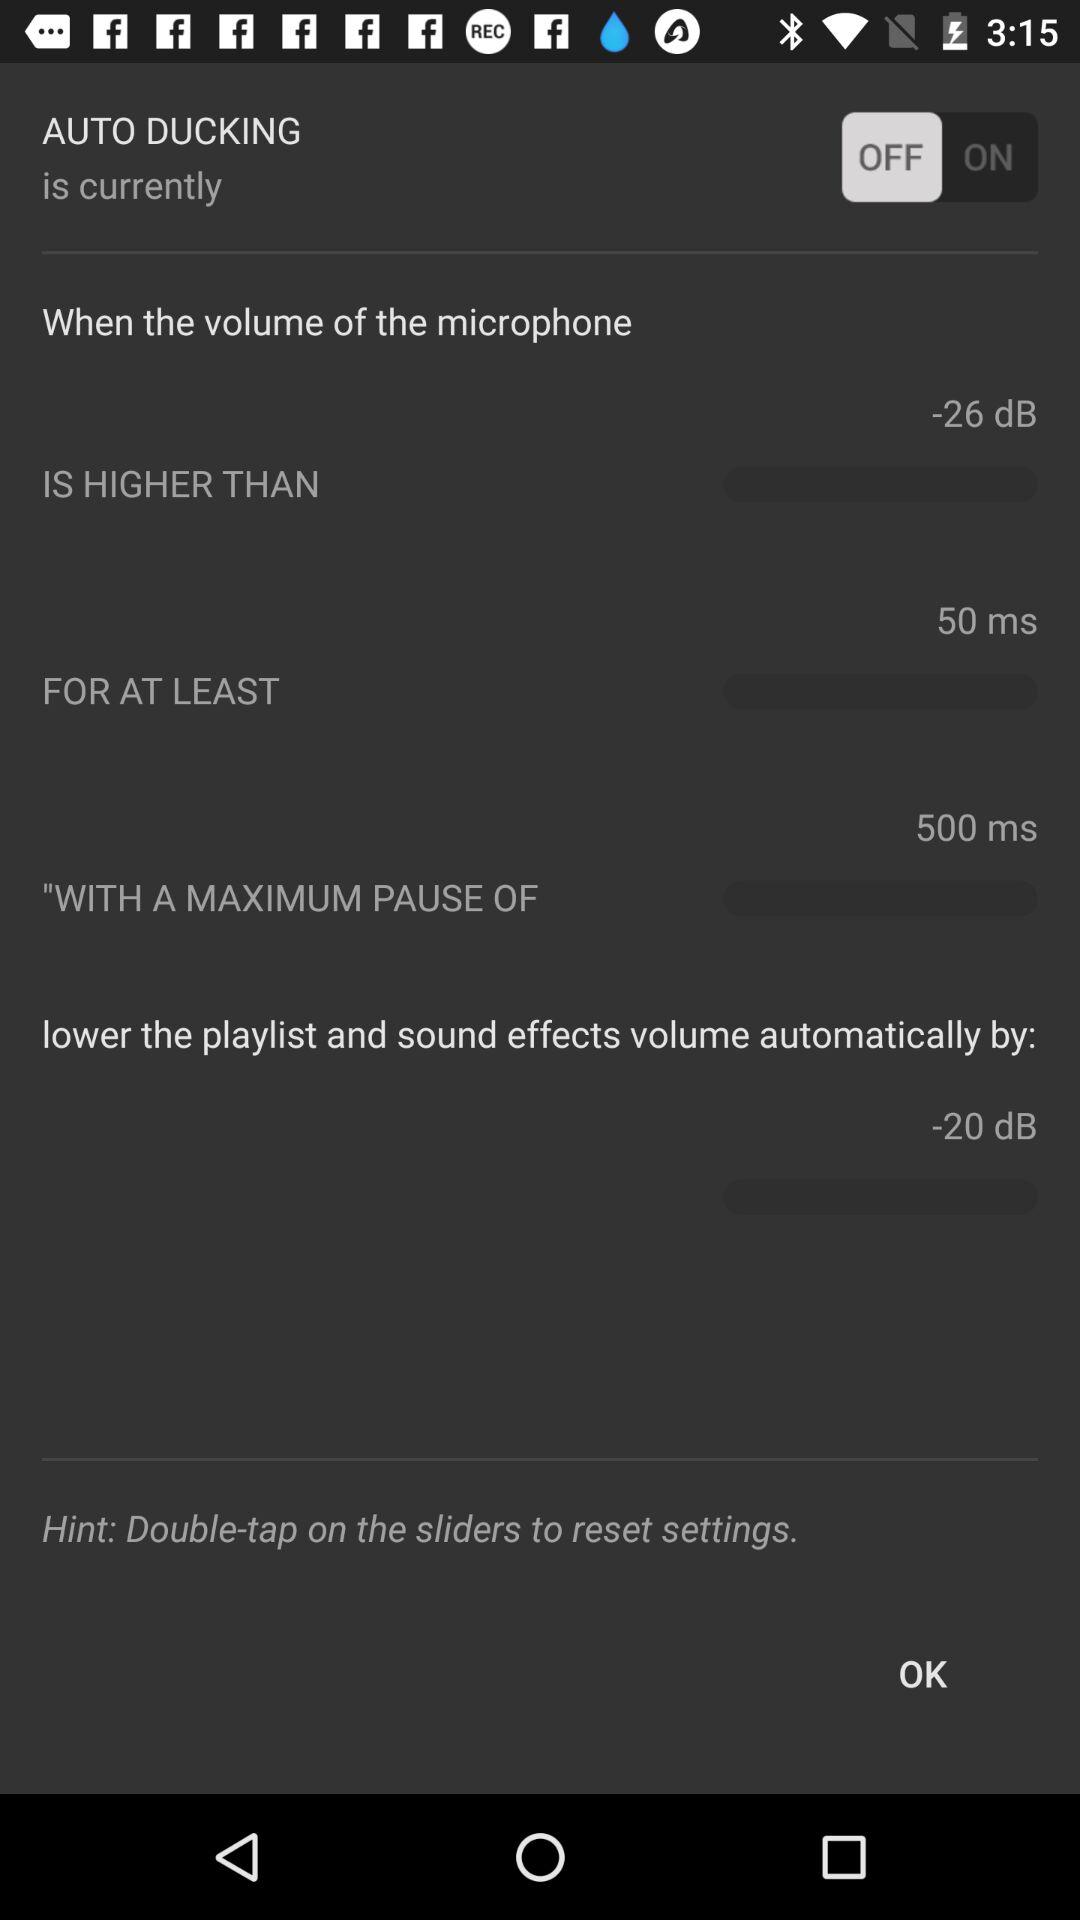How long is the maximum pause between ducking events?
Answer the question using a single word or phrase. 500 ms 